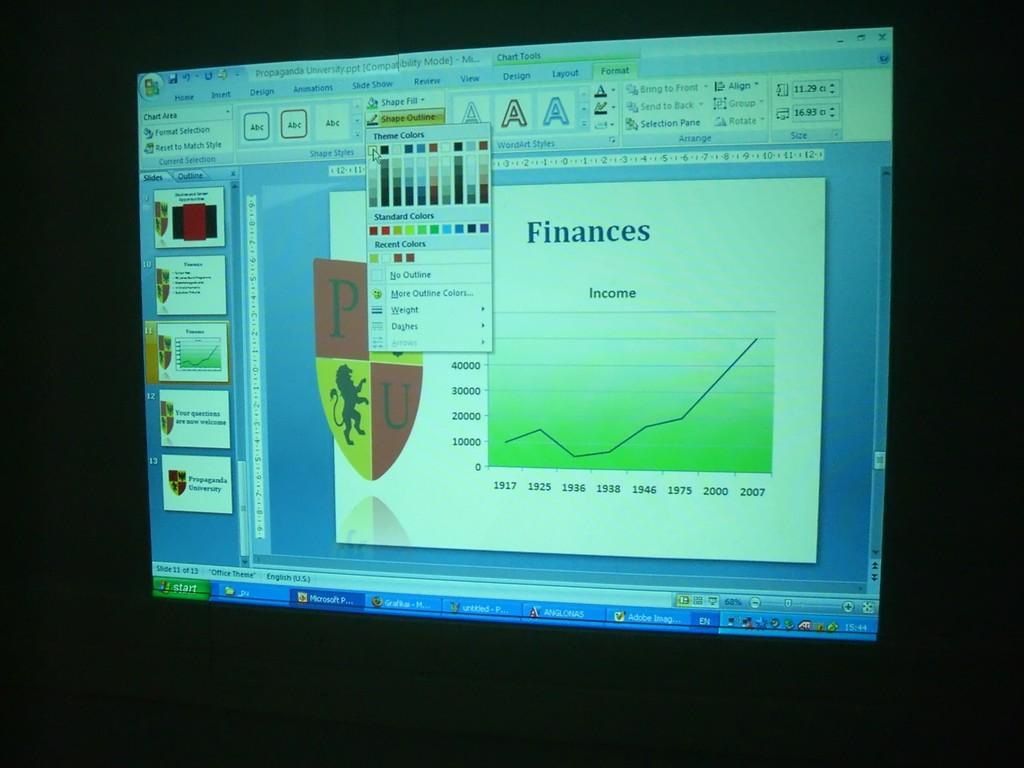<image>
Provide a brief description of the given image. A computer screen is displaying a slide show about Finances in the making 